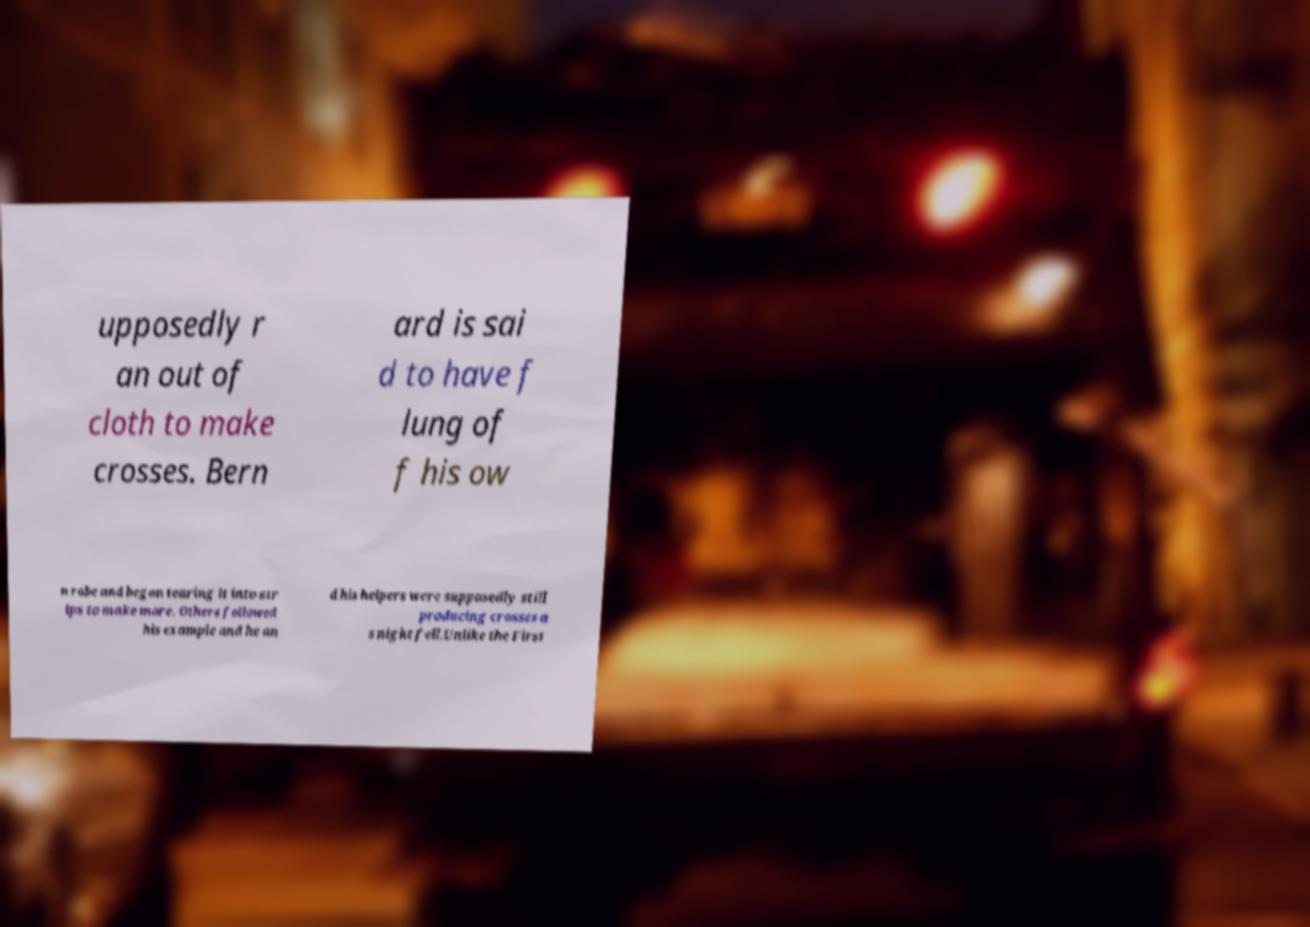Could you extract and type out the text from this image? upposedly r an out of cloth to make crosses. Bern ard is sai d to have f lung of f his ow n robe and began tearing it into str ips to make more. Others followed his example and he an d his helpers were supposedly still producing crosses a s night fell.Unlike the First 